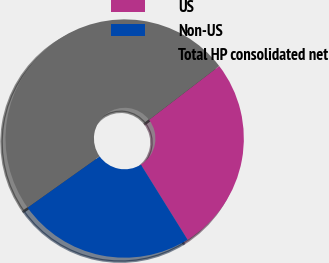<chart> <loc_0><loc_0><loc_500><loc_500><pie_chart><fcel>US<fcel>Non-US<fcel>Total HP consolidated net<nl><fcel>26.56%<fcel>24.02%<fcel>49.42%<nl></chart> 